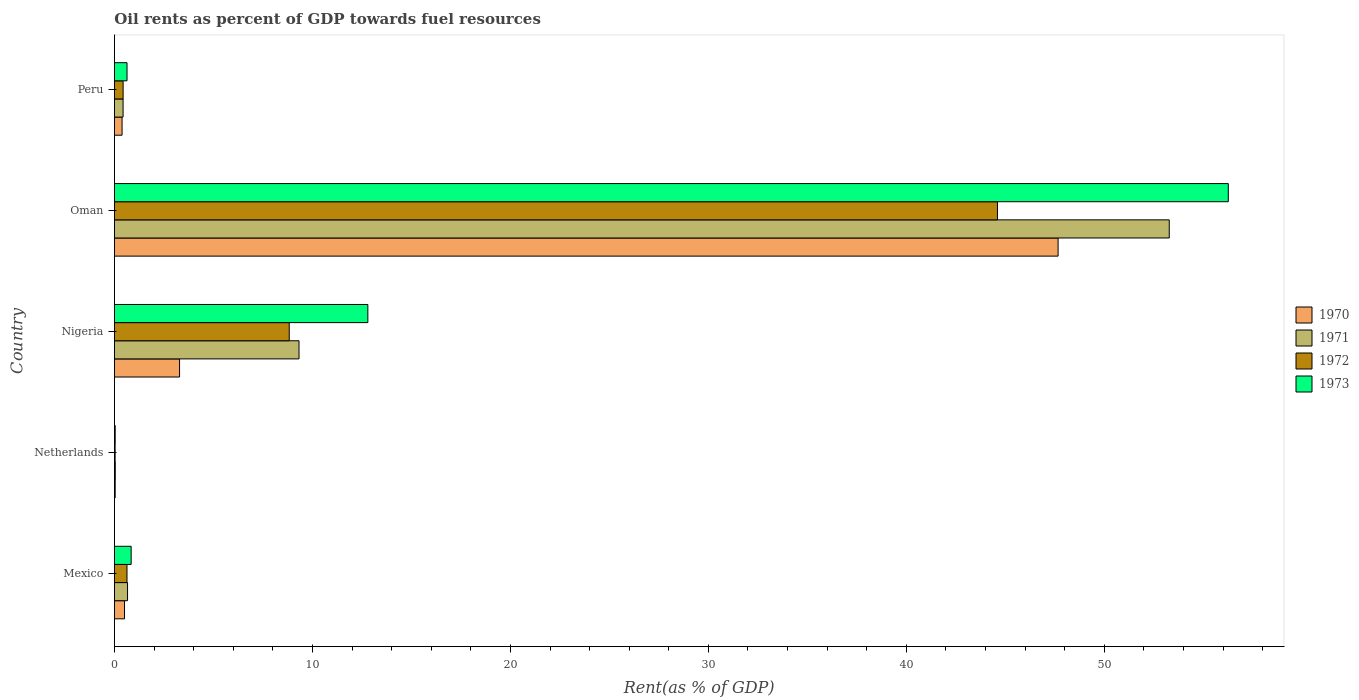How many different coloured bars are there?
Your answer should be very brief. 4. Are the number of bars per tick equal to the number of legend labels?
Your answer should be very brief. Yes. How many bars are there on the 5th tick from the top?
Ensure brevity in your answer.  4. How many bars are there on the 1st tick from the bottom?
Make the answer very short. 4. In how many cases, is the number of bars for a given country not equal to the number of legend labels?
Your answer should be very brief. 0. What is the oil rent in 1971 in Peru?
Your answer should be very brief. 0.44. Across all countries, what is the maximum oil rent in 1970?
Give a very brief answer. 47.66. Across all countries, what is the minimum oil rent in 1973?
Your answer should be very brief. 0.04. In which country was the oil rent in 1973 maximum?
Provide a short and direct response. Oman. In which country was the oil rent in 1971 minimum?
Your answer should be compact. Netherlands. What is the total oil rent in 1971 in the graph?
Provide a short and direct response. 63.74. What is the difference between the oil rent in 1973 in Mexico and that in Oman?
Your answer should be compact. -55.41. What is the difference between the oil rent in 1973 in Nigeria and the oil rent in 1970 in Netherlands?
Ensure brevity in your answer.  12.76. What is the average oil rent in 1971 per country?
Offer a terse response. 12.75. What is the difference between the oil rent in 1972 and oil rent in 1973 in Peru?
Your answer should be compact. -0.2. What is the ratio of the oil rent in 1970 in Nigeria to that in Oman?
Make the answer very short. 0.07. Is the oil rent in 1971 in Mexico less than that in Peru?
Keep it short and to the point. No. Is the difference between the oil rent in 1972 in Mexico and Oman greater than the difference between the oil rent in 1973 in Mexico and Oman?
Your response must be concise. Yes. What is the difference between the highest and the second highest oil rent in 1970?
Give a very brief answer. 44.37. What is the difference between the highest and the lowest oil rent in 1971?
Give a very brief answer. 53.23. What does the 2nd bar from the top in Nigeria represents?
Offer a very short reply. 1972. How many bars are there?
Make the answer very short. 20. Are the values on the major ticks of X-axis written in scientific E-notation?
Give a very brief answer. No. Where does the legend appear in the graph?
Your answer should be very brief. Center right. What is the title of the graph?
Keep it short and to the point. Oil rents as percent of GDP towards fuel resources. Does "1970" appear as one of the legend labels in the graph?
Your answer should be very brief. Yes. What is the label or title of the X-axis?
Provide a succinct answer. Rent(as % of GDP). What is the Rent(as % of GDP) of 1970 in Mexico?
Make the answer very short. 0.51. What is the Rent(as % of GDP) in 1971 in Mexico?
Keep it short and to the point. 0.66. What is the Rent(as % of GDP) in 1972 in Mexico?
Make the answer very short. 0.63. What is the Rent(as % of GDP) of 1973 in Mexico?
Provide a short and direct response. 0.84. What is the Rent(as % of GDP) in 1970 in Netherlands?
Offer a very short reply. 0.04. What is the Rent(as % of GDP) in 1971 in Netherlands?
Your answer should be compact. 0.04. What is the Rent(as % of GDP) of 1972 in Netherlands?
Make the answer very short. 0.03. What is the Rent(as % of GDP) of 1973 in Netherlands?
Ensure brevity in your answer.  0.04. What is the Rent(as % of GDP) of 1970 in Nigeria?
Offer a terse response. 3.29. What is the Rent(as % of GDP) of 1971 in Nigeria?
Make the answer very short. 9.32. What is the Rent(as % of GDP) in 1972 in Nigeria?
Provide a succinct answer. 8.83. What is the Rent(as % of GDP) in 1973 in Nigeria?
Provide a short and direct response. 12.8. What is the Rent(as % of GDP) in 1970 in Oman?
Provide a succinct answer. 47.66. What is the Rent(as % of GDP) of 1971 in Oman?
Provide a short and direct response. 53.28. What is the Rent(as % of GDP) of 1972 in Oman?
Provide a short and direct response. 44.6. What is the Rent(as % of GDP) of 1973 in Oman?
Make the answer very short. 56.26. What is the Rent(as % of GDP) in 1970 in Peru?
Offer a terse response. 0.39. What is the Rent(as % of GDP) in 1971 in Peru?
Provide a succinct answer. 0.44. What is the Rent(as % of GDP) in 1972 in Peru?
Offer a terse response. 0.44. What is the Rent(as % of GDP) in 1973 in Peru?
Keep it short and to the point. 0.64. Across all countries, what is the maximum Rent(as % of GDP) of 1970?
Your response must be concise. 47.66. Across all countries, what is the maximum Rent(as % of GDP) in 1971?
Keep it short and to the point. 53.28. Across all countries, what is the maximum Rent(as % of GDP) in 1972?
Provide a succinct answer. 44.6. Across all countries, what is the maximum Rent(as % of GDP) of 1973?
Give a very brief answer. 56.26. Across all countries, what is the minimum Rent(as % of GDP) in 1970?
Keep it short and to the point. 0.04. Across all countries, what is the minimum Rent(as % of GDP) in 1971?
Your response must be concise. 0.04. Across all countries, what is the minimum Rent(as % of GDP) in 1972?
Give a very brief answer. 0.03. Across all countries, what is the minimum Rent(as % of GDP) in 1973?
Offer a very short reply. 0.04. What is the total Rent(as % of GDP) of 1970 in the graph?
Your answer should be very brief. 51.88. What is the total Rent(as % of GDP) of 1971 in the graph?
Give a very brief answer. 63.74. What is the total Rent(as % of GDP) of 1972 in the graph?
Make the answer very short. 54.54. What is the total Rent(as % of GDP) of 1973 in the graph?
Offer a very short reply. 70.58. What is the difference between the Rent(as % of GDP) of 1970 in Mexico and that in Netherlands?
Keep it short and to the point. 0.47. What is the difference between the Rent(as % of GDP) in 1971 in Mexico and that in Netherlands?
Give a very brief answer. 0.62. What is the difference between the Rent(as % of GDP) in 1972 in Mexico and that in Netherlands?
Your answer should be very brief. 0.6. What is the difference between the Rent(as % of GDP) of 1973 in Mexico and that in Netherlands?
Offer a terse response. 0.81. What is the difference between the Rent(as % of GDP) of 1970 in Mexico and that in Nigeria?
Your answer should be compact. -2.78. What is the difference between the Rent(as % of GDP) in 1971 in Mexico and that in Nigeria?
Your answer should be very brief. -8.66. What is the difference between the Rent(as % of GDP) in 1972 in Mexico and that in Nigeria?
Your response must be concise. -8.19. What is the difference between the Rent(as % of GDP) of 1973 in Mexico and that in Nigeria?
Offer a terse response. -11.95. What is the difference between the Rent(as % of GDP) in 1970 in Mexico and that in Oman?
Make the answer very short. -47.15. What is the difference between the Rent(as % of GDP) of 1971 in Mexico and that in Oman?
Keep it short and to the point. -52.61. What is the difference between the Rent(as % of GDP) of 1972 in Mexico and that in Oman?
Offer a terse response. -43.97. What is the difference between the Rent(as % of GDP) of 1973 in Mexico and that in Oman?
Your answer should be very brief. -55.41. What is the difference between the Rent(as % of GDP) in 1970 in Mexico and that in Peru?
Keep it short and to the point. 0.12. What is the difference between the Rent(as % of GDP) in 1971 in Mexico and that in Peru?
Provide a short and direct response. 0.23. What is the difference between the Rent(as % of GDP) of 1972 in Mexico and that in Peru?
Your answer should be compact. 0.2. What is the difference between the Rent(as % of GDP) of 1973 in Mexico and that in Peru?
Give a very brief answer. 0.21. What is the difference between the Rent(as % of GDP) of 1970 in Netherlands and that in Nigeria?
Offer a very short reply. -3.25. What is the difference between the Rent(as % of GDP) in 1971 in Netherlands and that in Nigeria?
Ensure brevity in your answer.  -9.28. What is the difference between the Rent(as % of GDP) of 1972 in Netherlands and that in Nigeria?
Offer a very short reply. -8.79. What is the difference between the Rent(as % of GDP) of 1973 in Netherlands and that in Nigeria?
Offer a terse response. -12.76. What is the difference between the Rent(as % of GDP) of 1970 in Netherlands and that in Oman?
Your response must be concise. -47.62. What is the difference between the Rent(as % of GDP) of 1971 in Netherlands and that in Oman?
Provide a short and direct response. -53.23. What is the difference between the Rent(as % of GDP) of 1972 in Netherlands and that in Oman?
Your response must be concise. -44.57. What is the difference between the Rent(as % of GDP) of 1973 in Netherlands and that in Oman?
Make the answer very short. -56.22. What is the difference between the Rent(as % of GDP) of 1970 in Netherlands and that in Peru?
Offer a very short reply. -0.35. What is the difference between the Rent(as % of GDP) of 1971 in Netherlands and that in Peru?
Your answer should be compact. -0.39. What is the difference between the Rent(as % of GDP) of 1972 in Netherlands and that in Peru?
Provide a succinct answer. -0.4. What is the difference between the Rent(as % of GDP) of 1973 in Netherlands and that in Peru?
Make the answer very short. -0.6. What is the difference between the Rent(as % of GDP) in 1970 in Nigeria and that in Oman?
Offer a terse response. -44.37. What is the difference between the Rent(as % of GDP) of 1971 in Nigeria and that in Oman?
Ensure brevity in your answer.  -43.95. What is the difference between the Rent(as % of GDP) in 1972 in Nigeria and that in Oman?
Provide a short and direct response. -35.77. What is the difference between the Rent(as % of GDP) in 1973 in Nigeria and that in Oman?
Provide a succinct answer. -43.46. What is the difference between the Rent(as % of GDP) in 1970 in Nigeria and that in Peru?
Your response must be concise. 2.9. What is the difference between the Rent(as % of GDP) of 1971 in Nigeria and that in Peru?
Make the answer very short. 8.89. What is the difference between the Rent(as % of GDP) in 1972 in Nigeria and that in Peru?
Your answer should be very brief. 8.39. What is the difference between the Rent(as % of GDP) of 1973 in Nigeria and that in Peru?
Offer a very short reply. 12.16. What is the difference between the Rent(as % of GDP) in 1970 in Oman and that in Peru?
Your response must be concise. 47.28. What is the difference between the Rent(as % of GDP) in 1971 in Oman and that in Peru?
Give a very brief answer. 52.84. What is the difference between the Rent(as % of GDP) of 1972 in Oman and that in Peru?
Make the answer very short. 44.16. What is the difference between the Rent(as % of GDP) in 1973 in Oman and that in Peru?
Your answer should be very brief. 55.62. What is the difference between the Rent(as % of GDP) in 1970 in Mexico and the Rent(as % of GDP) in 1971 in Netherlands?
Your answer should be very brief. 0.47. What is the difference between the Rent(as % of GDP) of 1970 in Mexico and the Rent(as % of GDP) of 1972 in Netherlands?
Your response must be concise. 0.47. What is the difference between the Rent(as % of GDP) of 1970 in Mexico and the Rent(as % of GDP) of 1973 in Netherlands?
Give a very brief answer. 0.47. What is the difference between the Rent(as % of GDP) of 1971 in Mexico and the Rent(as % of GDP) of 1972 in Netherlands?
Provide a succinct answer. 0.63. What is the difference between the Rent(as % of GDP) of 1971 in Mexico and the Rent(as % of GDP) of 1973 in Netherlands?
Ensure brevity in your answer.  0.62. What is the difference between the Rent(as % of GDP) in 1972 in Mexico and the Rent(as % of GDP) in 1973 in Netherlands?
Offer a terse response. 0.6. What is the difference between the Rent(as % of GDP) of 1970 in Mexico and the Rent(as % of GDP) of 1971 in Nigeria?
Your answer should be compact. -8.81. What is the difference between the Rent(as % of GDP) of 1970 in Mexico and the Rent(as % of GDP) of 1972 in Nigeria?
Offer a very short reply. -8.32. What is the difference between the Rent(as % of GDP) in 1970 in Mexico and the Rent(as % of GDP) in 1973 in Nigeria?
Ensure brevity in your answer.  -12.29. What is the difference between the Rent(as % of GDP) of 1971 in Mexico and the Rent(as % of GDP) of 1972 in Nigeria?
Offer a very short reply. -8.17. What is the difference between the Rent(as % of GDP) of 1971 in Mexico and the Rent(as % of GDP) of 1973 in Nigeria?
Offer a terse response. -12.14. What is the difference between the Rent(as % of GDP) in 1972 in Mexico and the Rent(as % of GDP) in 1973 in Nigeria?
Provide a succinct answer. -12.16. What is the difference between the Rent(as % of GDP) in 1970 in Mexico and the Rent(as % of GDP) in 1971 in Oman?
Make the answer very short. -52.77. What is the difference between the Rent(as % of GDP) in 1970 in Mexico and the Rent(as % of GDP) in 1972 in Oman?
Ensure brevity in your answer.  -44.09. What is the difference between the Rent(as % of GDP) of 1970 in Mexico and the Rent(as % of GDP) of 1973 in Oman?
Offer a terse response. -55.75. What is the difference between the Rent(as % of GDP) of 1971 in Mexico and the Rent(as % of GDP) of 1972 in Oman?
Provide a short and direct response. -43.94. What is the difference between the Rent(as % of GDP) in 1971 in Mexico and the Rent(as % of GDP) in 1973 in Oman?
Make the answer very short. -55.6. What is the difference between the Rent(as % of GDP) in 1972 in Mexico and the Rent(as % of GDP) in 1973 in Oman?
Your response must be concise. -55.62. What is the difference between the Rent(as % of GDP) in 1970 in Mexico and the Rent(as % of GDP) in 1971 in Peru?
Your answer should be compact. 0.07. What is the difference between the Rent(as % of GDP) of 1970 in Mexico and the Rent(as % of GDP) of 1972 in Peru?
Make the answer very short. 0.07. What is the difference between the Rent(as % of GDP) in 1970 in Mexico and the Rent(as % of GDP) in 1973 in Peru?
Your answer should be very brief. -0.13. What is the difference between the Rent(as % of GDP) in 1971 in Mexico and the Rent(as % of GDP) in 1972 in Peru?
Offer a terse response. 0.22. What is the difference between the Rent(as % of GDP) of 1971 in Mexico and the Rent(as % of GDP) of 1973 in Peru?
Your answer should be very brief. 0.03. What is the difference between the Rent(as % of GDP) of 1972 in Mexico and the Rent(as % of GDP) of 1973 in Peru?
Give a very brief answer. -0. What is the difference between the Rent(as % of GDP) in 1970 in Netherlands and the Rent(as % of GDP) in 1971 in Nigeria?
Offer a terse response. -9.29. What is the difference between the Rent(as % of GDP) in 1970 in Netherlands and the Rent(as % of GDP) in 1972 in Nigeria?
Keep it short and to the point. -8.79. What is the difference between the Rent(as % of GDP) in 1970 in Netherlands and the Rent(as % of GDP) in 1973 in Nigeria?
Provide a succinct answer. -12.76. What is the difference between the Rent(as % of GDP) of 1971 in Netherlands and the Rent(as % of GDP) of 1972 in Nigeria?
Offer a very short reply. -8.79. What is the difference between the Rent(as % of GDP) in 1971 in Netherlands and the Rent(as % of GDP) in 1973 in Nigeria?
Keep it short and to the point. -12.76. What is the difference between the Rent(as % of GDP) of 1972 in Netherlands and the Rent(as % of GDP) of 1973 in Nigeria?
Your answer should be very brief. -12.76. What is the difference between the Rent(as % of GDP) of 1970 in Netherlands and the Rent(as % of GDP) of 1971 in Oman?
Provide a short and direct response. -53.24. What is the difference between the Rent(as % of GDP) in 1970 in Netherlands and the Rent(as % of GDP) in 1972 in Oman?
Your response must be concise. -44.56. What is the difference between the Rent(as % of GDP) of 1970 in Netherlands and the Rent(as % of GDP) of 1973 in Oman?
Offer a very short reply. -56.22. What is the difference between the Rent(as % of GDP) in 1971 in Netherlands and the Rent(as % of GDP) in 1972 in Oman?
Keep it short and to the point. -44.56. What is the difference between the Rent(as % of GDP) in 1971 in Netherlands and the Rent(as % of GDP) in 1973 in Oman?
Ensure brevity in your answer.  -56.22. What is the difference between the Rent(as % of GDP) of 1972 in Netherlands and the Rent(as % of GDP) of 1973 in Oman?
Keep it short and to the point. -56.22. What is the difference between the Rent(as % of GDP) in 1970 in Netherlands and the Rent(as % of GDP) in 1971 in Peru?
Provide a succinct answer. -0.4. What is the difference between the Rent(as % of GDP) in 1970 in Netherlands and the Rent(as % of GDP) in 1972 in Peru?
Make the answer very short. -0.4. What is the difference between the Rent(as % of GDP) in 1970 in Netherlands and the Rent(as % of GDP) in 1973 in Peru?
Keep it short and to the point. -0.6. What is the difference between the Rent(as % of GDP) of 1971 in Netherlands and the Rent(as % of GDP) of 1972 in Peru?
Your response must be concise. -0.4. What is the difference between the Rent(as % of GDP) in 1971 in Netherlands and the Rent(as % of GDP) in 1973 in Peru?
Provide a short and direct response. -0.59. What is the difference between the Rent(as % of GDP) of 1972 in Netherlands and the Rent(as % of GDP) of 1973 in Peru?
Your answer should be compact. -0.6. What is the difference between the Rent(as % of GDP) of 1970 in Nigeria and the Rent(as % of GDP) of 1971 in Oman?
Your answer should be very brief. -49.99. What is the difference between the Rent(as % of GDP) in 1970 in Nigeria and the Rent(as % of GDP) in 1972 in Oman?
Keep it short and to the point. -41.31. What is the difference between the Rent(as % of GDP) of 1970 in Nigeria and the Rent(as % of GDP) of 1973 in Oman?
Your answer should be very brief. -52.97. What is the difference between the Rent(as % of GDP) of 1971 in Nigeria and the Rent(as % of GDP) of 1972 in Oman?
Keep it short and to the point. -35.28. What is the difference between the Rent(as % of GDP) in 1971 in Nigeria and the Rent(as % of GDP) in 1973 in Oman?
Your answer should be compact. -46.94. What is the difference between the Rent(as % of GDP) of 1972 in Nigeria and the Rent(as % of GDP) of 1973 in Oman?
Your answer should be very brief. -47.43. What is the difference between the Rent(as % of GDP) of 1970 in Nigeria and the Rent(as % of GDP) of 1971 in Peru?
Keep it short and to the point. 2.85. What is the difference between the Rent(as % of GDP) in 1970 in Nigeria and the Rent(as % of GDP) in 1972 in Peru?
Ensure brevity in your answer.  2.85. What is the difference between the Rent(as % of GDP) in 1970 in Nigeria and the Rent(as % of GDP) in 1973 in Peru?
Your response must be concise. 2.65. What is the difference between the Rent(as % of GDP) in 1971 in Nigeria and the Rent(as % of GDP) in 1972 in Peru?
Offer a very short reply. 8.88. What is the difference between the Rent(as % of GDP) in 1971 in Nigeria and the Rent(as % of GDP) in 1973 in Peru?
Your answer should be very brief. 8.69. What is the difference between the Rent(as % of GDP) of 1972 in Nigeria and the Rent(as % of GDP) of 1973 in Peru?
Offer a very short reply. 8.19. What is the difference between the Rent(as % of GDP) in 1970 in Oman and the Rent(as % of GDP) in 1971 in Peru?
Make the answer very short. 47.23. What is the difference between the Rent(as % of GDP) of 1970 in Oman and the Rent(as % of GDP) of 1972 in Peru?
Offer a very short reply. 47.22. What is the difference between the Rent(as % of GDP) of 1970 in Oman and the Rent(as % of GDP) of 1973 in Peru?
Keep it short and to the point. 47.03. What is the difference between the Rent(as % of GDP) in 1971 in Oman and the Rent(as % of GDP) in 1972 in Peru?
Offer a terse response. 52.84. What is the difference between the Rent(as % of GDP) in 1971 in Oman and the Rent(as % of GDP) in 1973 in Peru?
Your answer should be compact. 52.64. What is the difference between the Rent(as % of GDP) in 1972 in Oman and the Rent(as % of GDP) in 1973 in Peru?
Keep it short and to the point. 43.96. What is the average Rent(as % of GDP) of 1970 per country?
Keep it short and to the point. 10.38. What is the average Rent(as % of GDP) in 1971 per country?
Provide a succinct answer. 12.75. What is the average Rent(as % of GDP) of 1972 per country?
Give a very brief answer. 10.91. What is the average Rent(as % of GDP) in 1973 per country?
Your response must be concise. 14.12. What is the difference between the Rent(as % of GDP) of 1970 and Rent(as % of GDP) of 1971 in Mexico?
Offer a terse response. -0.15. What is the difference between the Rent(as % of GDP) of 1970 and Rent(as % of GDP) of 1972 in Mexico?
Your response must be concise. -0.13. What is the difference between the Rent(as % of GDP) of 1970 and Rent(as % of GDP) of 1973 in Mexico?
Give a very brief answer. -0.34. What is the difference between the Rent(as % of GDP) in 1971 and Rent(as % of GDP) in 1972 in Mexico?
Your answer should be compact. 0.03. What is the difference between the Rent(as % of GDP) in 1971 and Rent(as % of GDP) in 1973 in Mexico?
Your answer should be very brief. -0.18. What is the difference between the Rent(as % of GDP) of 1972 and Rent(as % of GDP) of 1973 in Mexico?
Keep it short and to the point. -0.21. What is the difference between the Rent(as % of GDP) of 1970 and Rent(as % of GDP) of 1971 in Netherlands?
Your answer should be very brief. -0.01. What is the difference between the Rent(as % of GDP) in 1970 and Rent(as % of GDP) in 1972 in Netherlands?
Your answer should be compact. 0. What is the difference between the Rent(as % of GDP) of 1970 and Rent(as % of GDP) of 1973 in Netherlands?
Make the answer very short. -0. What is the difference between the Rent(as % of GDP) in 1971 and Rent(as % of GDP) in 1972 in Netherlands?
Keep it short and to the point. 0.01. What is the difference between the Rent(as % of GDP) of 1971 and Rent(as % of GDP) of 1973 in Netherlands?
Keep it short and to the point. 0. What is the difference between the Rent(as % of GDP) of 1972 and Rent(as % of GDP) of 1973 in Netherlands?
Offer a terse response. -0. What is the difference between the Rent(as % of GDP) in 1970 and Rent(as % of GDP) in 1971 in Nigeria?
Offer a very short reply. -6.03. What is the difference between the Rent(as % of GDP) in 1970 and Rent(as % of GDP) in 1972 in Nigeria?
Provide a short and direct response. -5.54. What is the difference between the Rent(as % of GDP) of 1970 and Rent(as % of GDP) of 1973 in Nigeria?
Make the answer very short. -9.51. What is the difference between the Rent(as % of GDP) in 1971 and Rent(as % of GDP) in 1972 in Nigeria?
Provide a succinct answer. 0.49. What is the difference between the Rent(as % of GDP) in 1971 and Rent(as % of GDP) in 1973 in Nigeria?
Your answer should be very brief. -3.48. What is the difference between the Rent(as % of GDP) in 1972 and Rent(as % of GDP) in 1973 in Nigeria?
Ensure brevity in your answer.  -3.97. What is the difference between the Rent(as % of GDP) of 1970 and Rent(as % of GDP) of 1971 in Oman?
Offer a terse response. -5.61. What is the difference between the Rent(as % of GDP) in 1970 and Rent(as % of GDP) in 1972 in Oman?
Provide a short and direct response. 3.06. What is the difference between the Rent(as % of GDP) of 1970 and Rent(as % of GDP) of 1973 in Oman?
Provide a succinct answer. -8.6. What is the difference between the Rent(as % of GDP) of 1971 and Rent(as % of GDP) of 1972 in Oman?
Make the answer very short. 8.68. What is the difference between the Rent(as % of GDP) of 1971 and Rent(as % of GDP) of 1973 in Oman?
Provide a short and direct response. -2.98. What is the difference between the Rent(as % of GDP) of 1972 and Rent(as % of GDP) of 1973 in Oman?
Offer a very short reply. -11.66. What is the difference between the Rent(as % of GDP) of 1970 and Rent(as % of GDP) of 1971 in Peru?
Make the answer very short. -0.05. What is the difference between the Rent(as % of GDP) of 1970 and Rent(as % of GDP) of 1972 in Peru?
Your answer should be very brief. -0.05. What is the difference between the Rent(as % of GDP) in 1970 and Rent(as % of GDP) in 1973 in Peru?
Your answer should be compact. -0.25. What is the difference between the Rent(as % of GDP) of 1971 and Rent(as % of GDP) of 1972 in Peru?
Your response must be concise. -0. What is the difference between the Rent(as % of GDP) of 1971 and Rent(as % of GDP) of 1973 in Peru?
Keep it short and to the point. -0.2. What is the difference between the Rent(as % of GDP) of 1972 and Rent(as % of GDP) of 1973 in Peru?
Keep it short and to the point. -0.2. What is the ratio of the Rent(as % of GDP) in 1970 in Mexico to that in Netherlands?
Your answer should be very brief. 13.43. What is the ratio of the Rent(as % of GDP) in 1971 in Mexico to that in Netherlands?
Your response must be concise. 15.37. What is the ratio of the Rent(as % of GDP) in 1972 in Mexico to that in Netherlands?
Your response must be concise. 18.28. What is the ratio of the Rent(as % of GDP) in 1973 in Mexico to that in Netherlands?
Keep it short and to the point. 21.38. What is the ratio of the Rent(as % of GDP) of 1970 in Mexico to that in Nigeria?
Your answer should be compact. 0.15. What is the ratio of the Rent(as % of GDP) in 1971 in Mexico to that in Nigeria?
Your answer should be very brief. 0.07. What is the ratio of the Rent(as % of GDP) in 1972 in Mexico to that in Nigeria?
Make the answer very short. 0.07. What is the ratio of the Rent(as % of GDP) of 1973 in Mexico to that in Nigeria?
Your response must be concise. 0.07. What is the ratio of the Rent(as % of GDP) in 1970 in Mexico to that in Oman?
Your answer should be compact. 0.01. What is the ratio of the Rent(as % of GDP) of 1971 in Mexico to that in Oman?
Provide a succinct answer. 0.01. What is the ratio of the Rent(as % of GDP) of 1972 in Mexico to that in Oman?
Offer a very short reply. 0.01. What is the ratio of the Rent(as % of GDP) of 1973 in Mexico to that in Oman?
Offer a terse response. 0.01. What is the ratio of the Rent(as % of GDP) in 1970 in Mexico to that in Peru?
Keep it short and to the point. 1.32. What is the ratio of the Rent(as % of GDP) of 1971 in Mexico to that in Peru?
Your answer should be very brief. 1.52. What is the ratio of the Rent(as % of GDP) of 1972 in Mexico to that in Peru?
Your answer should be compact. 1.45. What is the ratio of the Rent(as % of GDP) in 1973 in Mexico to that in Peru?
Make the answer very short. 1.33. What is the ratio of the Rent(as % of GDP) of 1970 in Netherlands to that in Nigeria?
Your answer should be very brief. 0.01. What is the ratio of the Rent(as % of GDP) in 1971 in Netherlands to that in Nigeria?
Offer a very short reply. 0. What is the ratio of the Rent(as % of GDP) in 1972 in Netherlands to that in Nigeria?
Make the answer very short. 0. What is the ratio of the Rent(as % of GDP) in 1973 in Netherlands to that in Nigeria?
Give a very brief answer. 0. What is the ratio of the Rent(as % of GDP) in 1970 in Netherlands to that in Oman?
Your answer should be very brief. 0. What is the ratio of the Rent(as % of GDP) of 1971 in Netherlands to that in Oman?
Your response must be concise. 0. What is the ratio of the Rent(as % of GDP) in 1972 in Netherlands to that in Oman?
Provide a succinct answer. 0. What is the ratio of the Rent(as % of GDP) of 1973 in Netherlands to that in Oman?
Keep it short and to the point. 0. What is the ratio of the Rent(as % of GDP) of 1970 in Netherlands to that in Peru?
Your answer should be compact. 0.1. What is the ratio of the Rent(as % of GDP) in 1971 in Netherlands to that in Peru?
Make the answer very short. 0.1. What is the ratio of the Rent(as % of GDP) of 1972 in Netherlands to that in Peru?
Give a very brief answer. 0.08. What is the ratio of the Rent(as % of GDP) of 1973 in Netherlands to that in Peru?
Ensure brevity in your answer.  0.06. What is the ratio of the Rent(as % of GDP) in 1970 in Nigeria to that in Oman?
Your response must be concise. 0.07. What is the ratio of the Rent(as % of GDP) of 1971 in Nigeria to that in Oman?
Offer a terse response. 0.17. What is the ratio of the Rent(as % of GDP) in 1972 in Nigeria to that in Oman?
Your answer should be very brief. 0.2. What is the ratio of the Rent(as % of GDP) of 1973 in Nigeria to that in Oman?
Offer a terse response. 0.23. What is the ratio of the Rent(as % of GDP) of 1970 in Nigeria to that in Peru?
Offer a very short reply. 8.53. What is the ratio of the Rent(as % of GDP) of 1971 in Nigeria to that in Peru?
Give a very brief answer. 21.35. What is the ratio of the Rent(as % of GDP) of 1972 in Nigeria to that in Peru?
Give a very brief answer. 20.12. What is the ratio of the Rent(as % of GDP) of 1973 in Nigeria to that in Peru?
Make the answer very short. 20.13. What is the ratio of the Rent(as % of GDP) in 1970 in Oman to that in Peru?
Provide a short and direct response. 123.65. What is the ratio of the Rent(as % of GDP) in 1971 in Oman to that in Peru?
Provide a short and direct response. 121.98. What is the ratio of the Rent(as % of GDP) in 1972 in Oman to that in Peru?
Offer a very short reply. 101.64. What is the ratio of the Rent(as % of GDP) in 1973 in Oman to that in Peru?
Give a very brief answer. 88.49. What is the difference between the highest and the second highest Rent(as % of GDP) in 1970?
Provide a short and direct response. 44.37. What is the difference between the highest and the second highest Rent(as % of GDP) in 1971?
Offer a terse response. 43.95. What is the difference between the highest and the second highest Rent(as % of GDP) in 1972?
Keep it short and to the point. 35.77. What is the difference between the highest and the second highest Rent(as % of GDP) of 1973?
Your response must be concise. 43.46. What is the difference between the highest and the lowest Rent(as % of GDP) of 1970?
Your answer should be very brief. 47.62. What is the difference between the highest and the lowest Rent(as % of GDP) in 1971?
Offer a terse response. 53.23. What is the difference between the highest and the lowest Rent(as % of GDP) of 1972?
Keep it short and to the point. 44.57. What is the difference between the highest and the lowest Rent(as % of GDP) in 1973?
Provide a succinct answer. 56.22. 